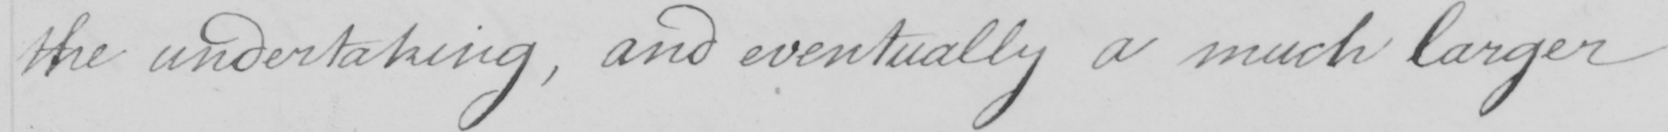What text is written in this handwritten line? the undertaking , and eventually a much larger 